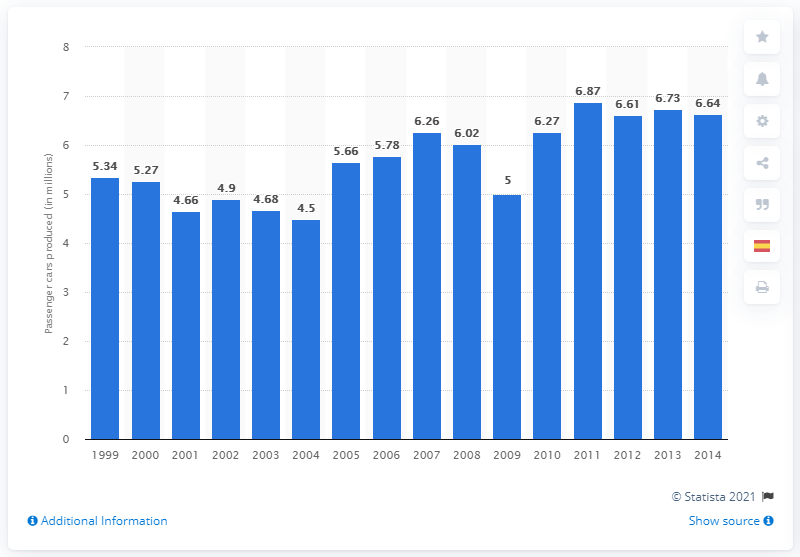Identify some key points in this picture. General Motors produced 6,641,748 passenger cars in 2013. 